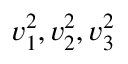<formula> <loc_0><loc_0><loc_500><loc_500>v _ { 1 } ^ { 2 } , v _ { 2 } ^ { 2 } , v _ { 3 } ^ { 2 }</formula> 